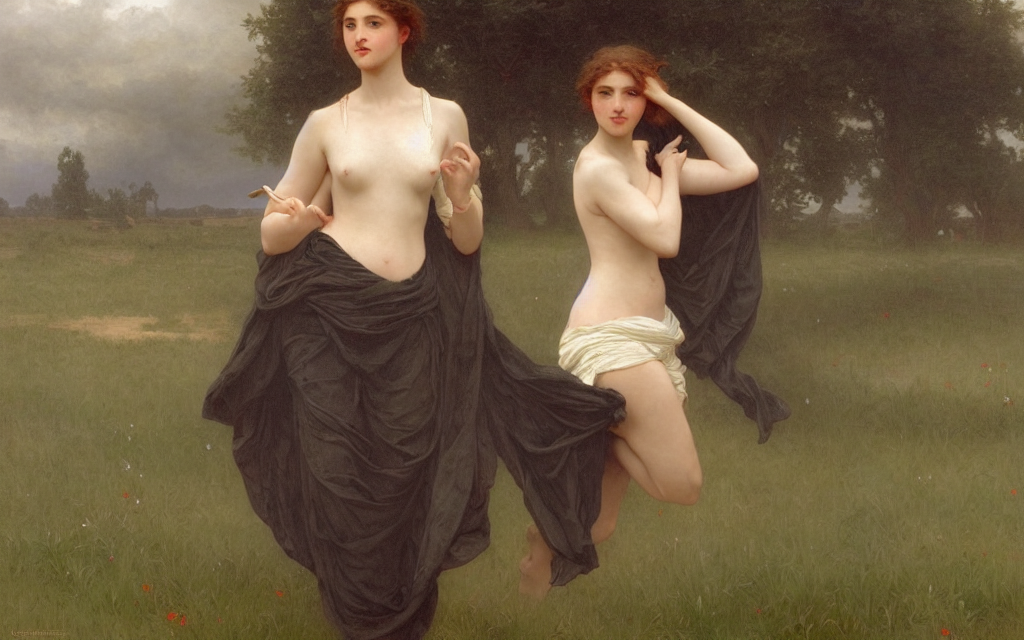Is the texture of the skin relatively clear?
A. Yes
B. No
Answer with the option's letter from the given choices directly.
 A. 